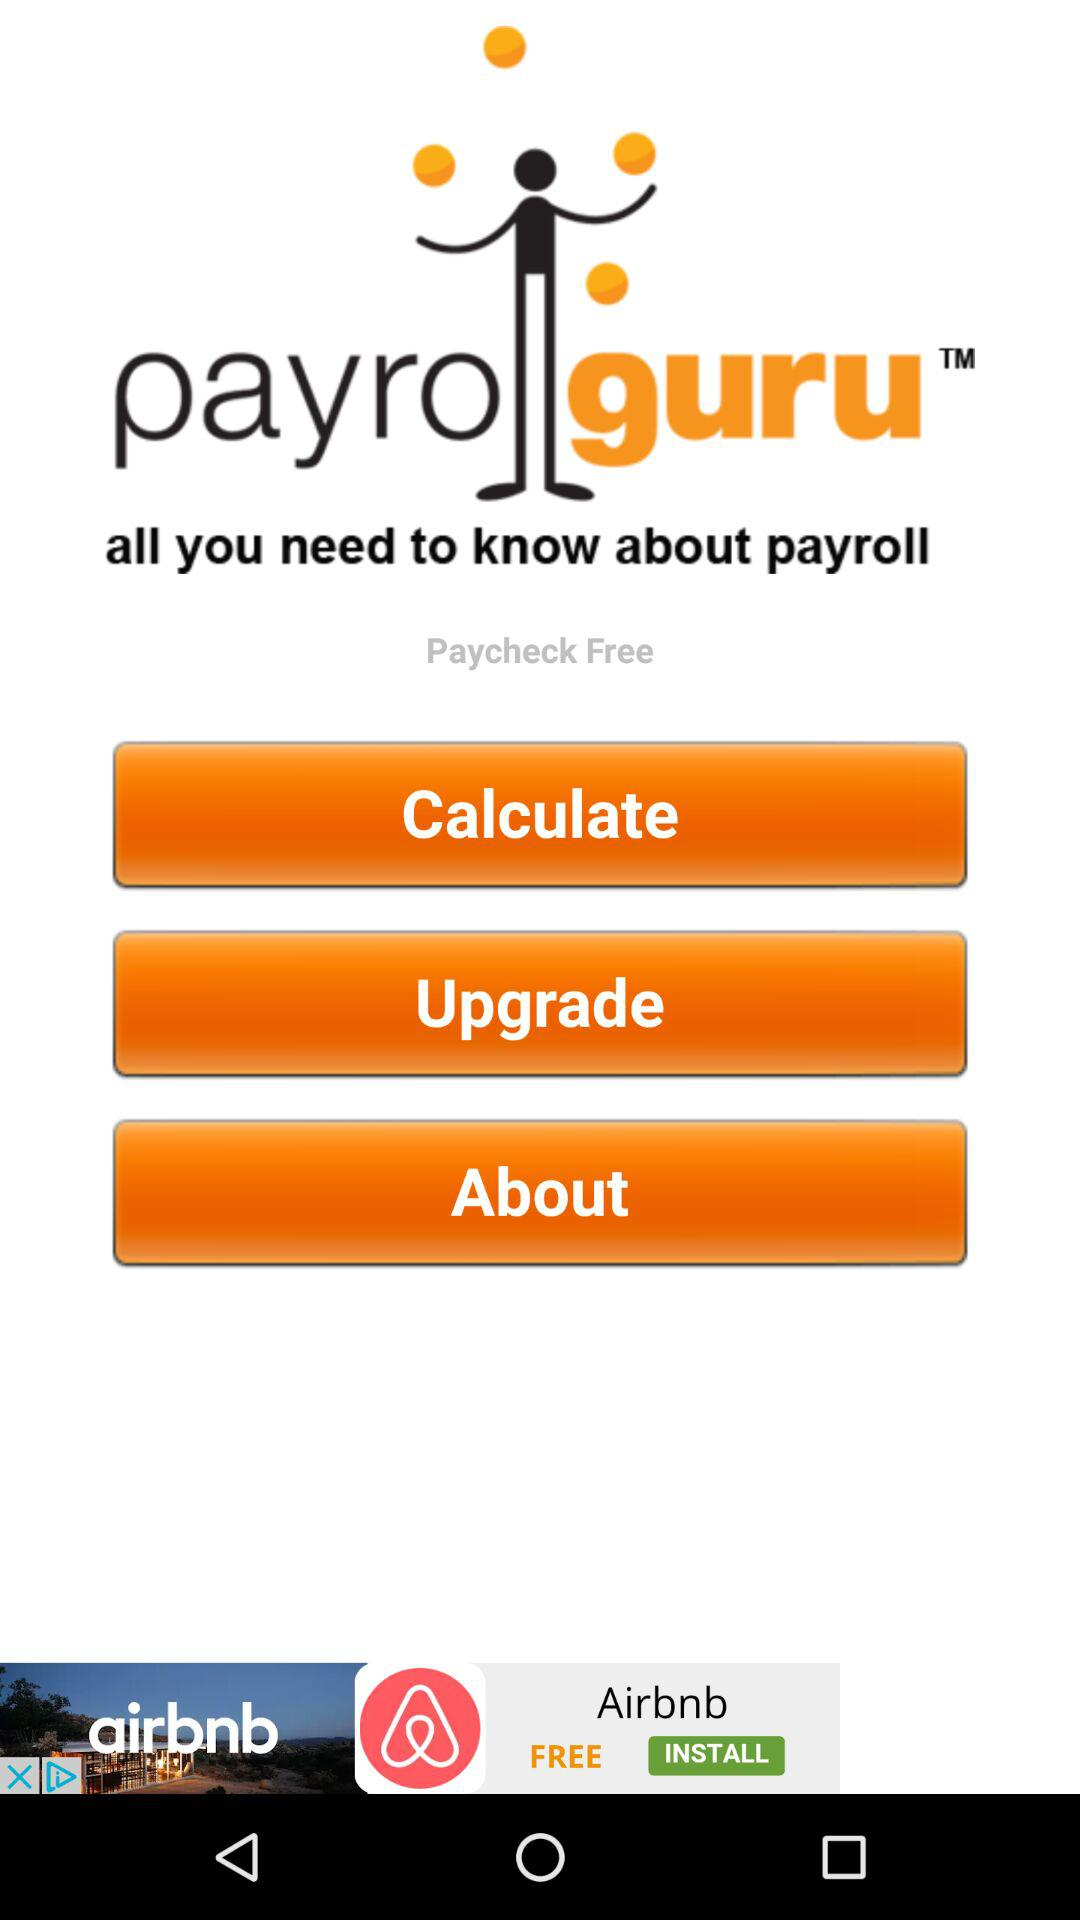How much does a paycheck cost?
When the provided information is insufficient, respond with <no answer>. <no answer> 